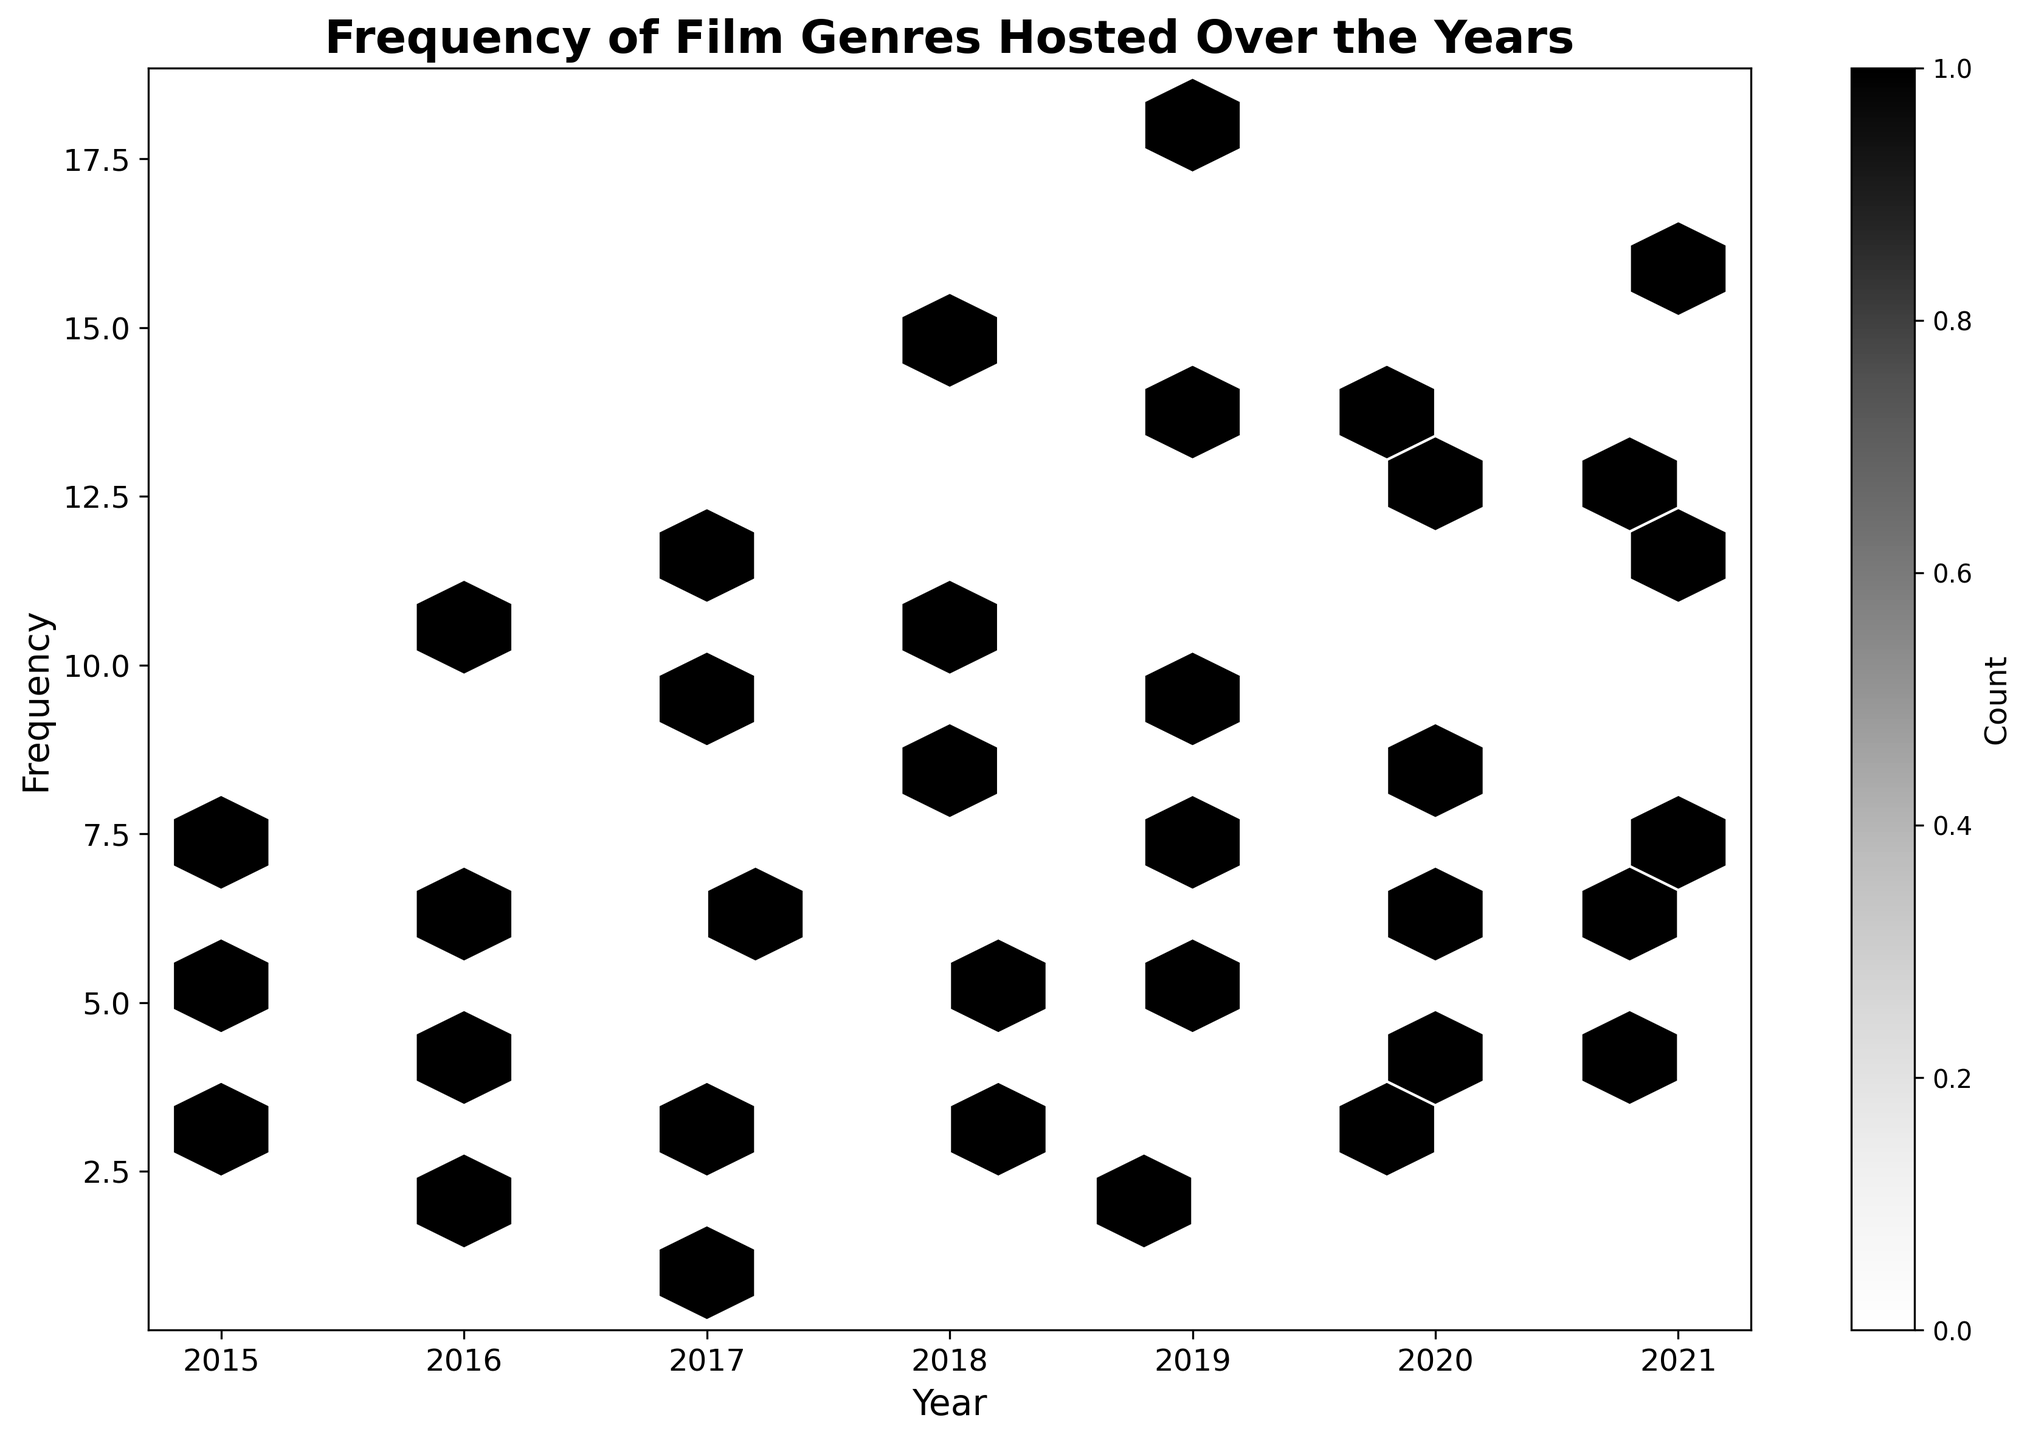What is the title of the figure? The title of the plot is placed prominently at the top. It gives context about what the figure represents.
Answer: Frequency of Film Genres Hosted Over the Years What does the hexbin plot measure on the y-axis? The label on the y-axis indicates what is being measured vertically.
Answer: Frequency Which years show the highest frequency of film genres? The hexbin plot shows darker or more densely packed hexagons for the years with higher frequencies. The hexagons around the years 2019-2021 are particularly dark.
Answer: 2019-2021 How does the frequency of film genres change over the years? By observing the density and color of hexagons along the x-axis, we can see the general trend. The frequency appears to increase from 2015 to 2019, then slightly fluctuates afterwards.
Answer: Increasing trend till 2019, then slight fluctuation Which year, on average, has the highest frequency of genres? To find this, look for the year with the most consistently dense hexagons (indicating high frequency) across different genres. 2019 seems to have the highest average density.
Answer: 2019 Compare the frequency of genres in 2021 and 2015. Which year hosted more films? Locate the hexbins corresponding to these years. Darker and denser hexagons are present in 2021 as compared to 2015, indicating a higher frequency of films in 2021.
Answer: 2021 hosted more films How many genres were added between 2015 and 2021? Count the additional rows from the data provided for each year to determine how many new genres have appeared over time. For 2015, there are 3 genres, while by 2021 there are 6 genres.
Answer: 3 new genres Is there any year where the frequencies are evenly distributed among genres? Look for years where the hexagons are spread out evenly in terms of color density. No particular year shows a completely even distribution, as some genres always have higher frequencies.
Answer: No What can you infer about the popularity of film genres over time? By examining the changes in hexbin density over the years for different genres, we can infer that certain genres have become more popular. For example, genres like Drama and Comedy show consistent and high frequency.
Answer: Popularity increased for Drama and Comedy Which genre appears to have the lowest frequency in 2019? Within the hexbin plot for 2019, look for the genre with the least dense hexagon, indicating lower frequency. Horror has the fewest occurrences.
Answer: Horror 